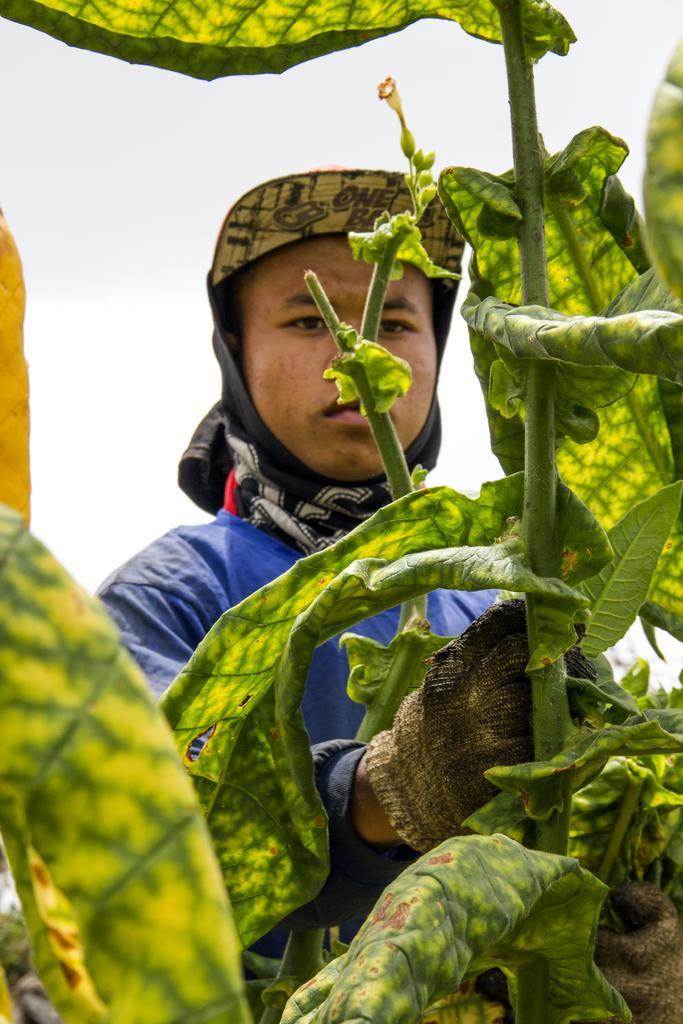Can you describe this image briefly? In this picture there is a man who is wearing blue jacket. He is near to the plants. On the bottom we can see leaves. In the back we can see sky and clouds. 